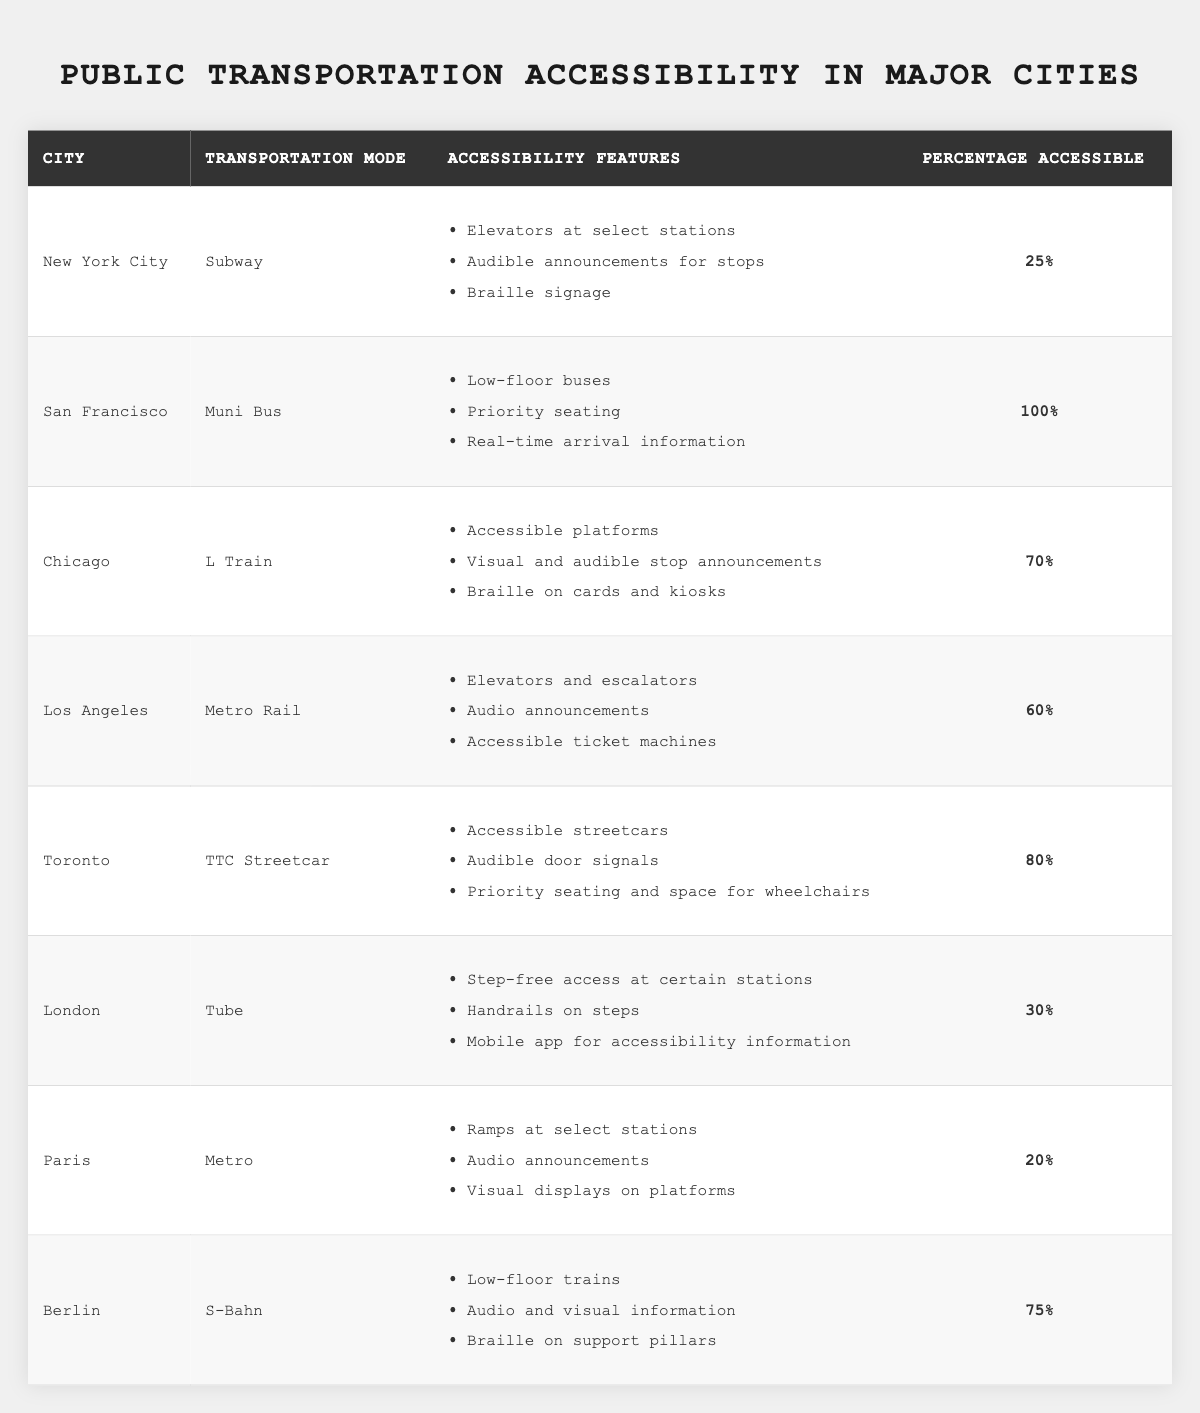What are the accessibility features of the Chicago L Train? The table lists the accessibility features for each transportation mode. For the Chicago L Train, the features are accessible platforms, visual and audible stop announcements, and Braille on cards and kiosks.
Answer: Accessible platforms, visual and audible stop announcements, and Braille on cards and kiosks Which city has the highest percentage of accessibility in public transportation? By reviewing the percentage accessible column in the table, San Francisco's Muni Bus has the highest percentage at 100%.
Answer: San Francisco How many cities have a percentage of accessible public transport below 30%? A count of the cities in the table reveals that New York City (25%), London (30%), and Paris (20%) all have percentages below 30%. Therefore, there are three cities with this characteristic.
Answer: Three What is the average percentage accessible across all listed cities? Sum the percentage accessible values: 25 + 100 + 70 + 60 + 80 + 30 + 20 + 75 = 460. Then divide by the number of cities (8): 460/8 = 57.5.
Answer: 57.5 Is the statement "Toronto has lower accessibility features than Berlin" true? Toronto has a percentage accessible of 80% with features like accessible streetcars and audible door signals; whereas Berlin has 75% with low-floor trains. Thus, the statement is false because Toronto has higher accessibility.
Answer: False Which city's Metro has ramps at select stations? The table indicates that ramps at select stations are a feature of the Paris Metro.
Answer: Paris What is the difference in accessibility percentage between Toronto and Los Angeles? Toronto has an accessibility percentage of 80% and Los Angeles has 60%. The difference is 80 - 60 = 20.
Answer: 20 Does the London Tube provide audible announcements for stops? The table does not list audible announcements as a feature for the London Tube, so the answer is no.
Answer: No How many transportation modes provide Braille signage? Looking through the table, Braille signage is noted for the subway in New York City, as well as with the L Train in Chicago and S-Bahn in Berlin. This totals three modes offering this feature.
Answer: Three 